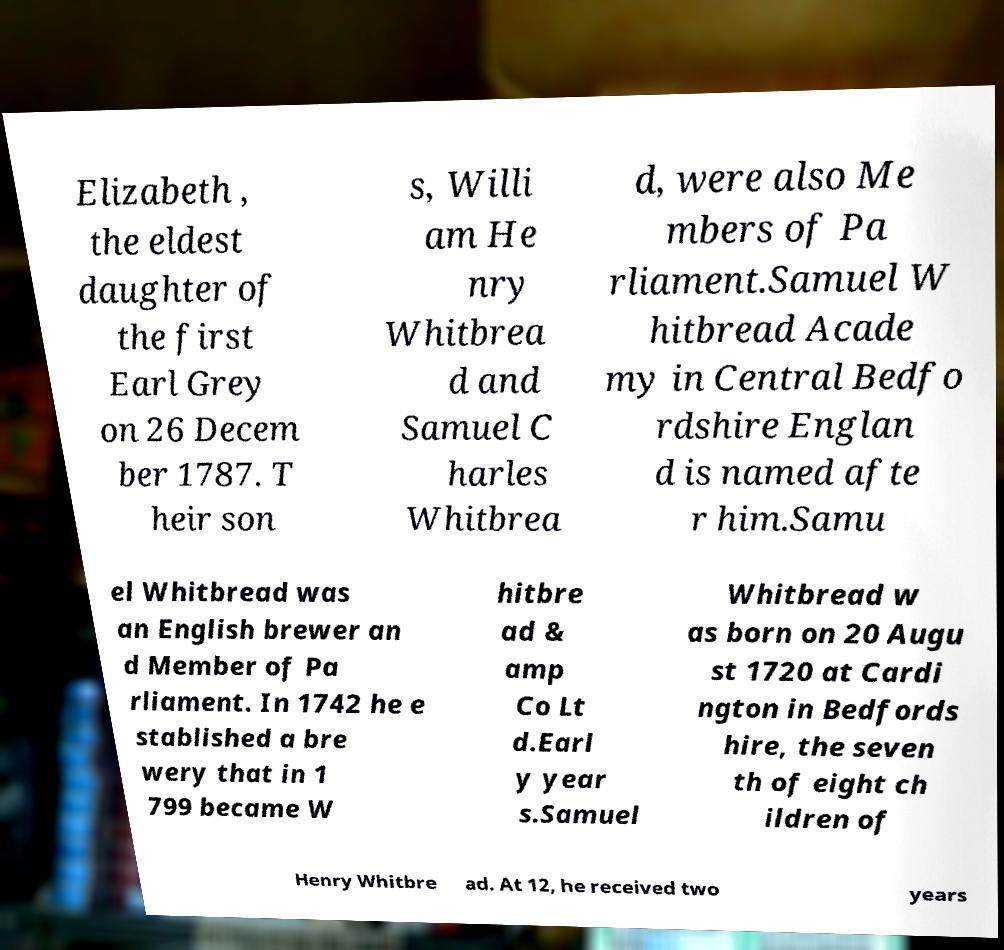Could you extract and type out the text from this image? Elizabeth , the eldest daughter of the first Earl Grey on 26 Decem ber 1787. T heir son s, Willi am He nry Whitbrea d and Samuel C harles Whitbrea d, were also Me mbers of Pa rliament.Samuel W hitbread Acade my in Central Bedfo rdshire Englan d is named afte r him.Samu el Whitbread was an English brewer an d Member of Pa rliament. In 1742 he e stablished a bre wery that in 1 799 became W hitbre ad & amp Co Lt d.Earl y year s.Samuel Whitbread w as born on 20 Augu st 1720 at Cardi ngton in Bedfords hire, the seven th of eight ch ildren of Henry Whitbre ad. At 12, he received two years 